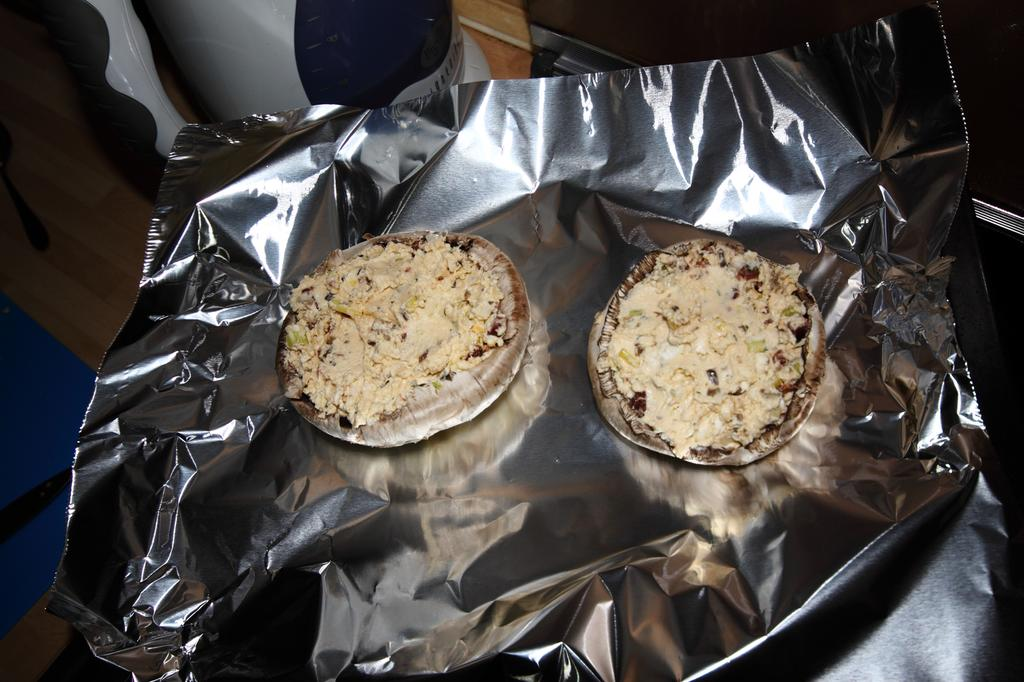What is the main subject of the image? There is a food item in the image in the image. How is the food item packaged or contained? The food item is in an aluminium sheet. What type of fish can be seen making a statement in the image? There is no fish present in the image, nor is there any indication of a statement being made. 